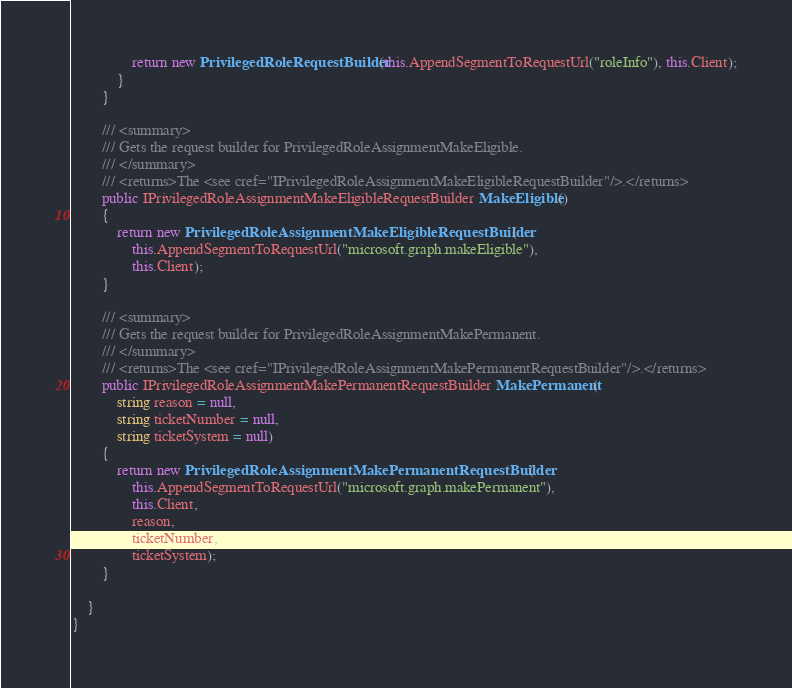Convert code to text. <code><loc_0><loc_0><loc_500><loc_500><_C#_>                return new PrivilegedRoleRequestBuilder(this.AppendSegmentToRequestUrl("roleInfo"), this.Client);
            }
        }
    
        /// <summary>
        /// Gets the request builder for PrivilegedRoleAssignmentMakeEligible.
        /// </summary>
        /// <returns>The <see cref="IPrivilegedRoleAssignmentMakeEligibleRequestBuilder"/>.</returns>
        public IPrivilegedRoleAssignmentMakeEligibleRequestBuilder MakeEligible()
        {
            return new PrivilegedRoleAssignmentMakeEligibleRequestBuilder(
                this.AppendSegmentToRequestUrl("microsoft.graph.makeEligible"),
                this.Client);
        }

        /// <summary>
        /// Gets the request builder for PrivilegedRoleAssignmentMakePermanent.
        /// </summary>
        /// <returns>The <see cref="IPrivilegedRoleAssignmentMakePermanentRequestBuilder"/>.</returns>
        public IPrivilegedRoleAssignmentMakePermanentRequestBuilder MakePermanent(
            string reason = null,
            string ticketNumber = null,
            string ticketSystem = null)
        {
            return new PrivilegedRoleAssignmentMakePermanentRequestBuilder(
                this.AppendSegmentToRequestUrl("microsoft.graph.makePermanent"),
                this.Client,
                reason,
                ticketNumber,
                ticketSystem);
        }
    
    }
}
</code> 